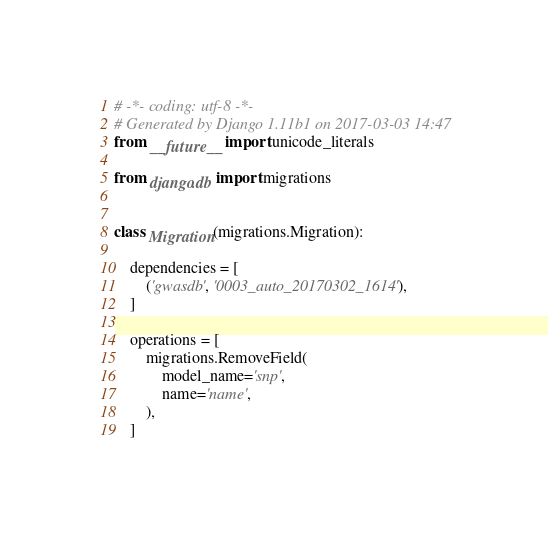<code> <loc_0><loc_0><loc_500><loc_500><_Python_># -*- coding: utf-8 -*-
# Generated by Django 1.11b1 on 2017-03-03 14:47
from __future__ import unicode_literals

from django.db import migrations


class Migration(migrations.Migration):

    dependencies = [
        ('gwasdb', '0003_auto_20170302_1614'),
    ]

    operations = [
        migrations.RemoveField(
            model_name='snp',
            name='name',
        ),
    ]
</code> 